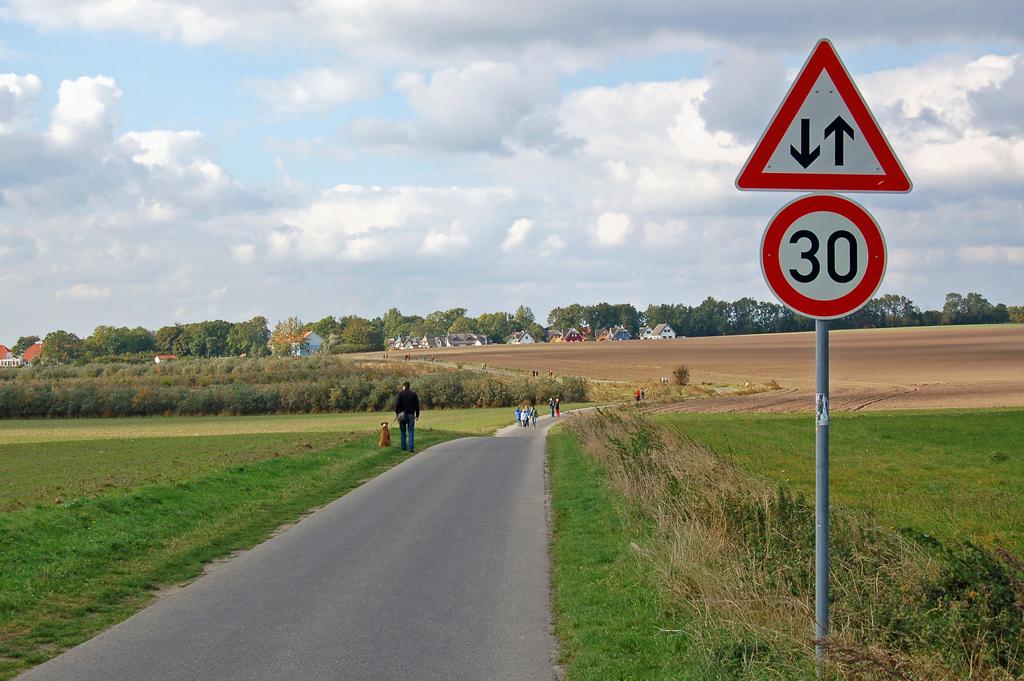What is the number on the road sign?
Keep it short and to the point. 30. 